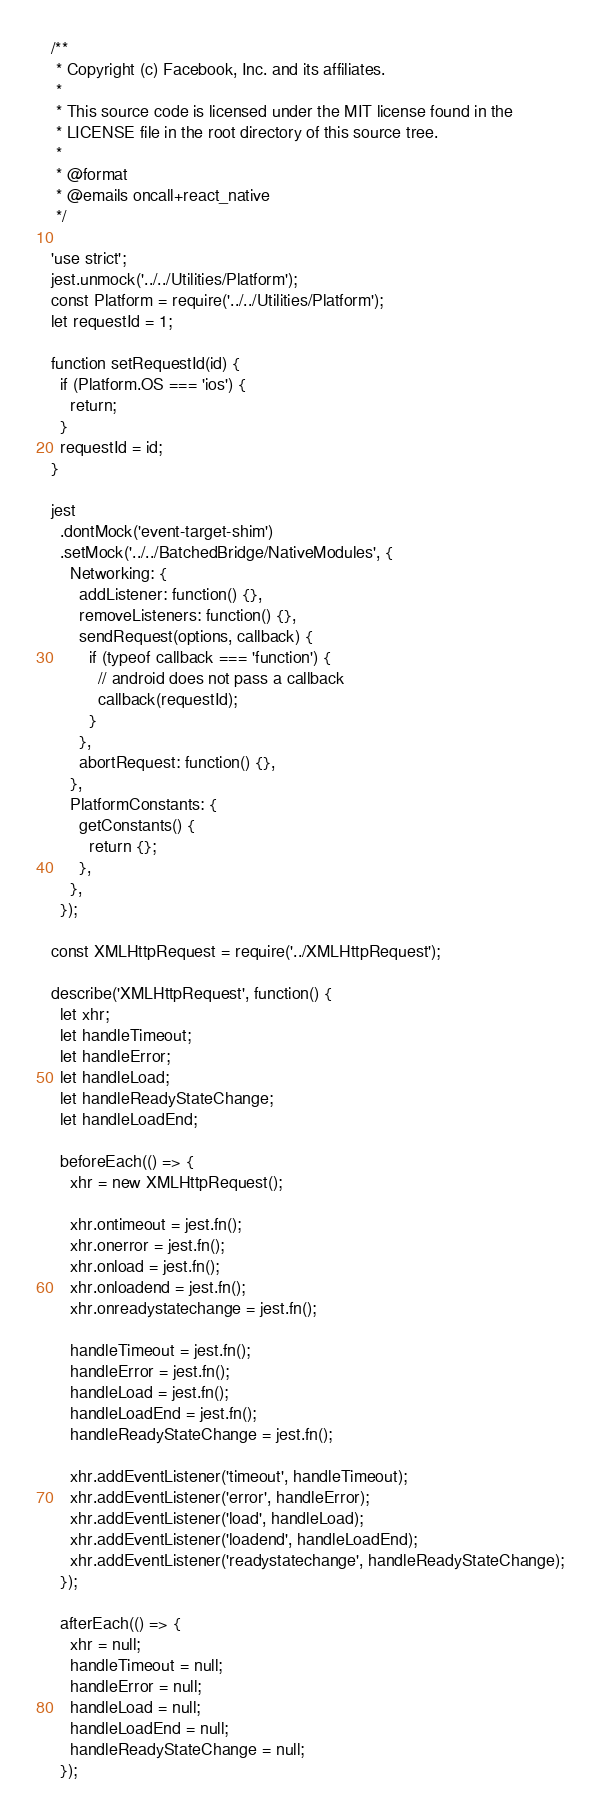<code> <loc_0><loc_0><loc_500><loc_500><_JavaScript_>/**
 * Copyright (c) Facebook, Inc. and its affiliates.
 *
 * This source code is licensed under the MIT license found in the
 * LICENSE file in the root directory of this source tree.
 *
 * @format
 * @emails oncall+react_native
 */

'use strict';
jest.unmock('../../Utilities/Platform');
const Platform = require('../../Utilities/Platform');
let requestId = 1;

function setRequestId(id) {
  if (Platform.OS === 'ios') {
    return;
  }
  requestId = id;
}

jest
  .dontMock('event-target-shim')
  .setMock('../../BatchedBridge/NativeModules', {
    Networking: {
      addListener: function() {},
      removeListeners: function() {},
      sendRequest(options, callback) {
        if (typeof callback === 'function') {
          // android does not pass a callback
          callback(requestId);
        }
      },
      abortRequest: function() {},
    },
    PlatformConstants: {
      getConstants() {
        return {};
      },
    },
  });

const XMLHttpRequest = require('../XMLHttpRequest');

describe('XMLHttpRequest', function() {
  let xhr;
  let handleTimeout;
  let handleError;
  let handleLoad;
  let handleReadyStateChange;
  let handleLoadEnd;

  beforeEach(() => {
    xhr = new XMLHttpRequest();

    xhr.ontimeout = jest.fn();
    xhr.onerror = jest.fn();
    xhr.onload = jest.fn();
    xhr.onloadend = jest.fn();
    xhr.onreadystatechange = jest.fn();

    handleTimeout = jest.fn();
    handleError = jest.fn();
    handleLoad = jest.fn();
    handleLoadEnd = jest.fn();
    handleReadyStateChange = jest.fn();

    xhr.addEventListener('timeout', handleTimeout);
    xhr.addEventListener('error', handleError);
    xhr.addEventListener('load', handleLoad);
    xhr.addEventListener('loadend', handleLoadEnd);
    xhr.addEventListener('readystatechange', handleReadyStateChange);
  });

  afterEach(() => {
    xhr = null;
    handleTimeout = null;
    handleError = null;
    handleLoad = null;
    handleLoadEnd = null;
    handleReadyStateChange = null;
  });
</code> 